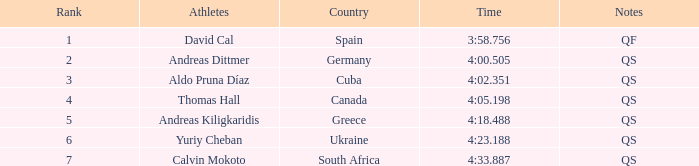What is calvin mokoto's mean position? 7.0. 